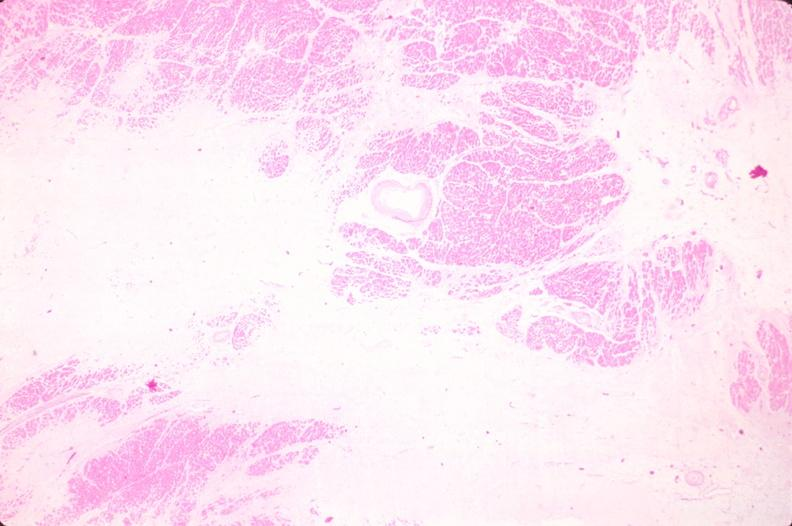what is present?
Answer the question using a single word or phrase. Cardiovascular 